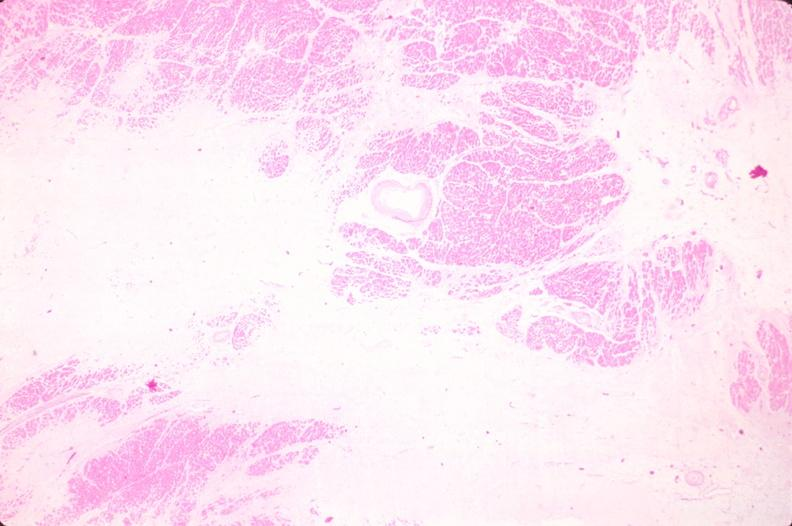what is present?
Answer the question using a single word or phrase. Cardiovascular 